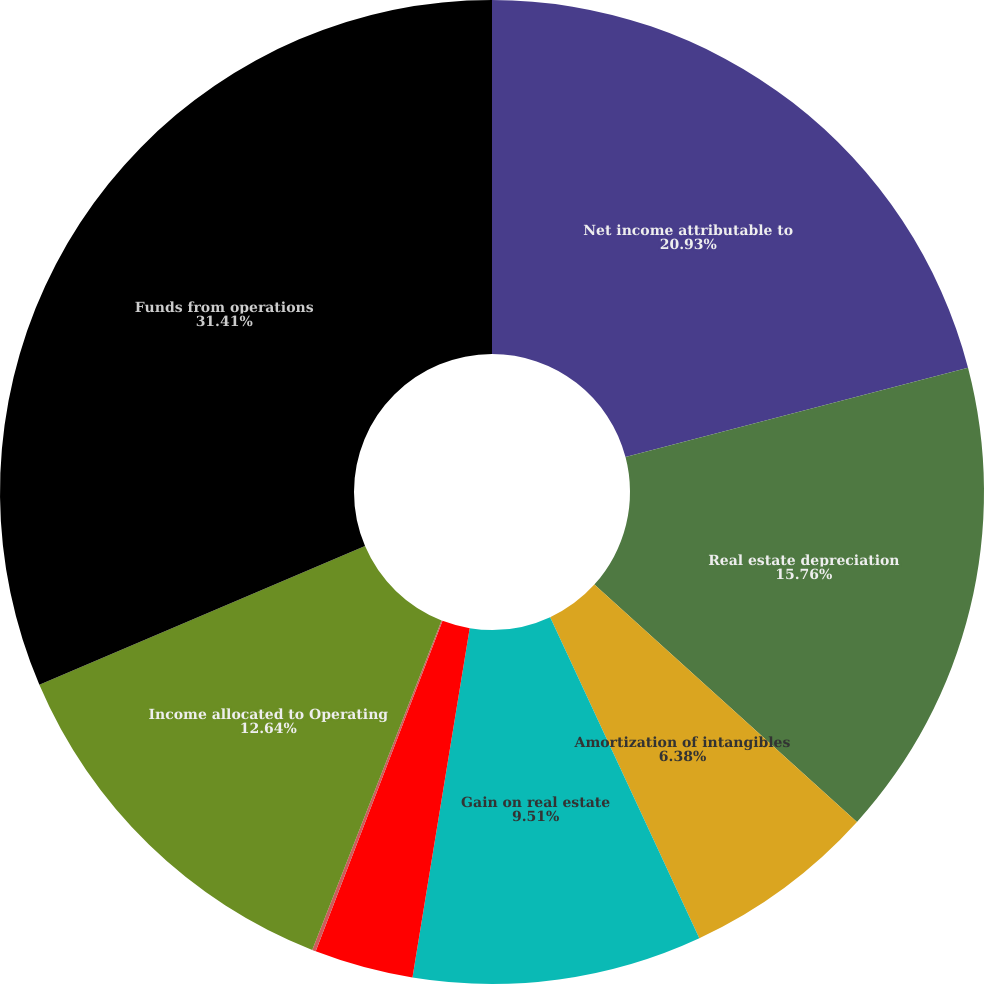<chart> <loc_0><loc_0><loc_500><loc_500><pie_chart><fcel>Net income attributable to<fcel>Real estate depreciation<fcel>Amortization of intangibles<fcel>Gain on real estate<fcel>Unconsolidated joint venture<fcel>Distributions paid on Series A<fcel>Income allocated to Operating<fcel>Funds from operations<nl><fcel>20.94%<fcel>15.77%<fcel>6.38%<fcel>9.51%<fcel>3.25%<fcel>0.12%<fcel>12.64%<fcel>31.42%<nl></chart> 